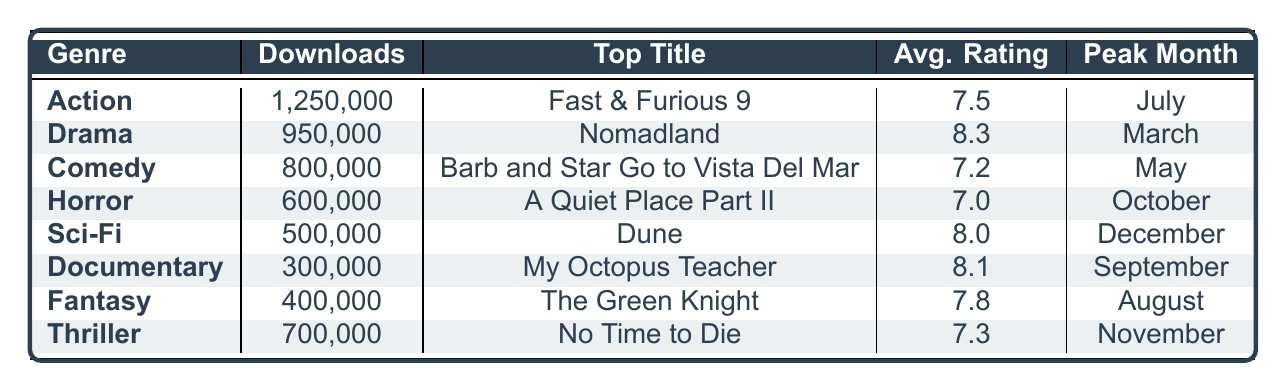What genre had the highest downloads last year? Referring to the "Downloads" column, Action has the highest value of 1,250,000 downloads, compared to other genres.
Answer: Action How many downloads did the Documentary genre receive last year? Looking at the "Downloads" column for Documentary, it shows 300,000 downloads.
Answer: 300,000 What is the average rating of the Comedy genre? The "Avg. Rating" column for Comedy shows a value of 7.2, which represents the average rating for this genre.
Answer: 7.2 Which genre peaked in October? The "Peak Month" column lists Horror as the genre with its peak month being October.
Answer: Horror What are the top titles for the Drama genre? The "Top Title" column for Drama lists the titles as Nomadland, The Father, and Judas and the Black Messiah.
Answer: Nomadland, The Father, Judas and the Black Messiah What is the difference in downloads between Action and Thriller genres? Action has 1,250,000 downloads, and Thriller has 700,000 downloads. The difference is 1,250,000 - 700,000 = 550,000.
Answer: 550,000 Which genre had the lowest average rating? By checking the "Avg. Rating" column, Horror is the only genre with an average rating of 7.0, which is lower than all other genres.
Answer: Yes Was Sci-Fi the genre with the highest downloads? No, it has 500,000 downloads, which is lower than Action (1,250,000) and Drama (950,000).
Answer: No Calculate the total downloads for all genres combined. Summing the downloads from all genres: 1,250,000 + 950,000 + 800,000 + 600,000 + 500,000 + 300,000 + 400,000 + 700,000 = 5,500,000.
Answer: 5,500,000 In which month did the Fantasy genre have its peak? According to the "Peak Month" column, Fantasy had its peak in August.
Answer: August 